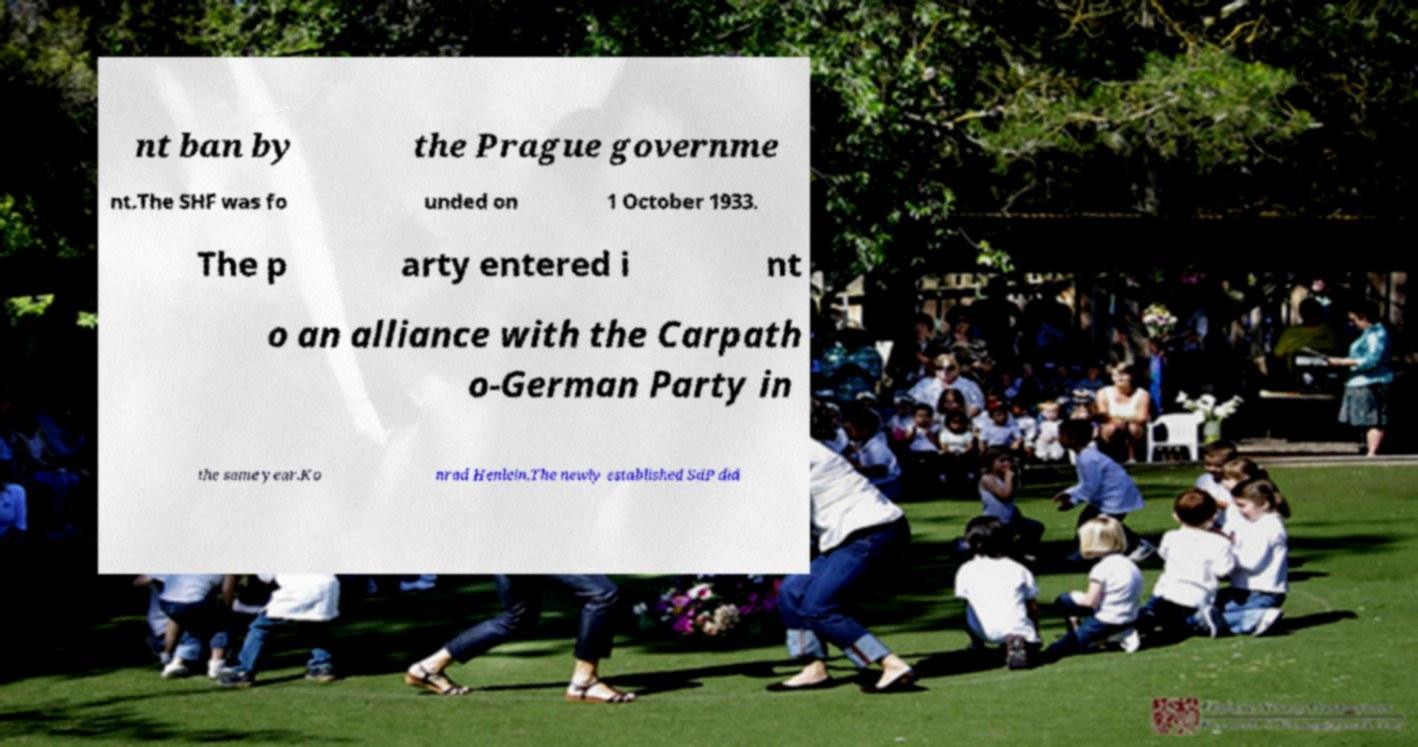Please identify and transcribe the text found in this image. nt ban by the Prague governme nt.The SHF was fo unded on 1 October 1933. The p arty entered i nt o an alliance with the Carpath o-German Party in the same year.Ko nrad Henlein.The newly established SdP did 